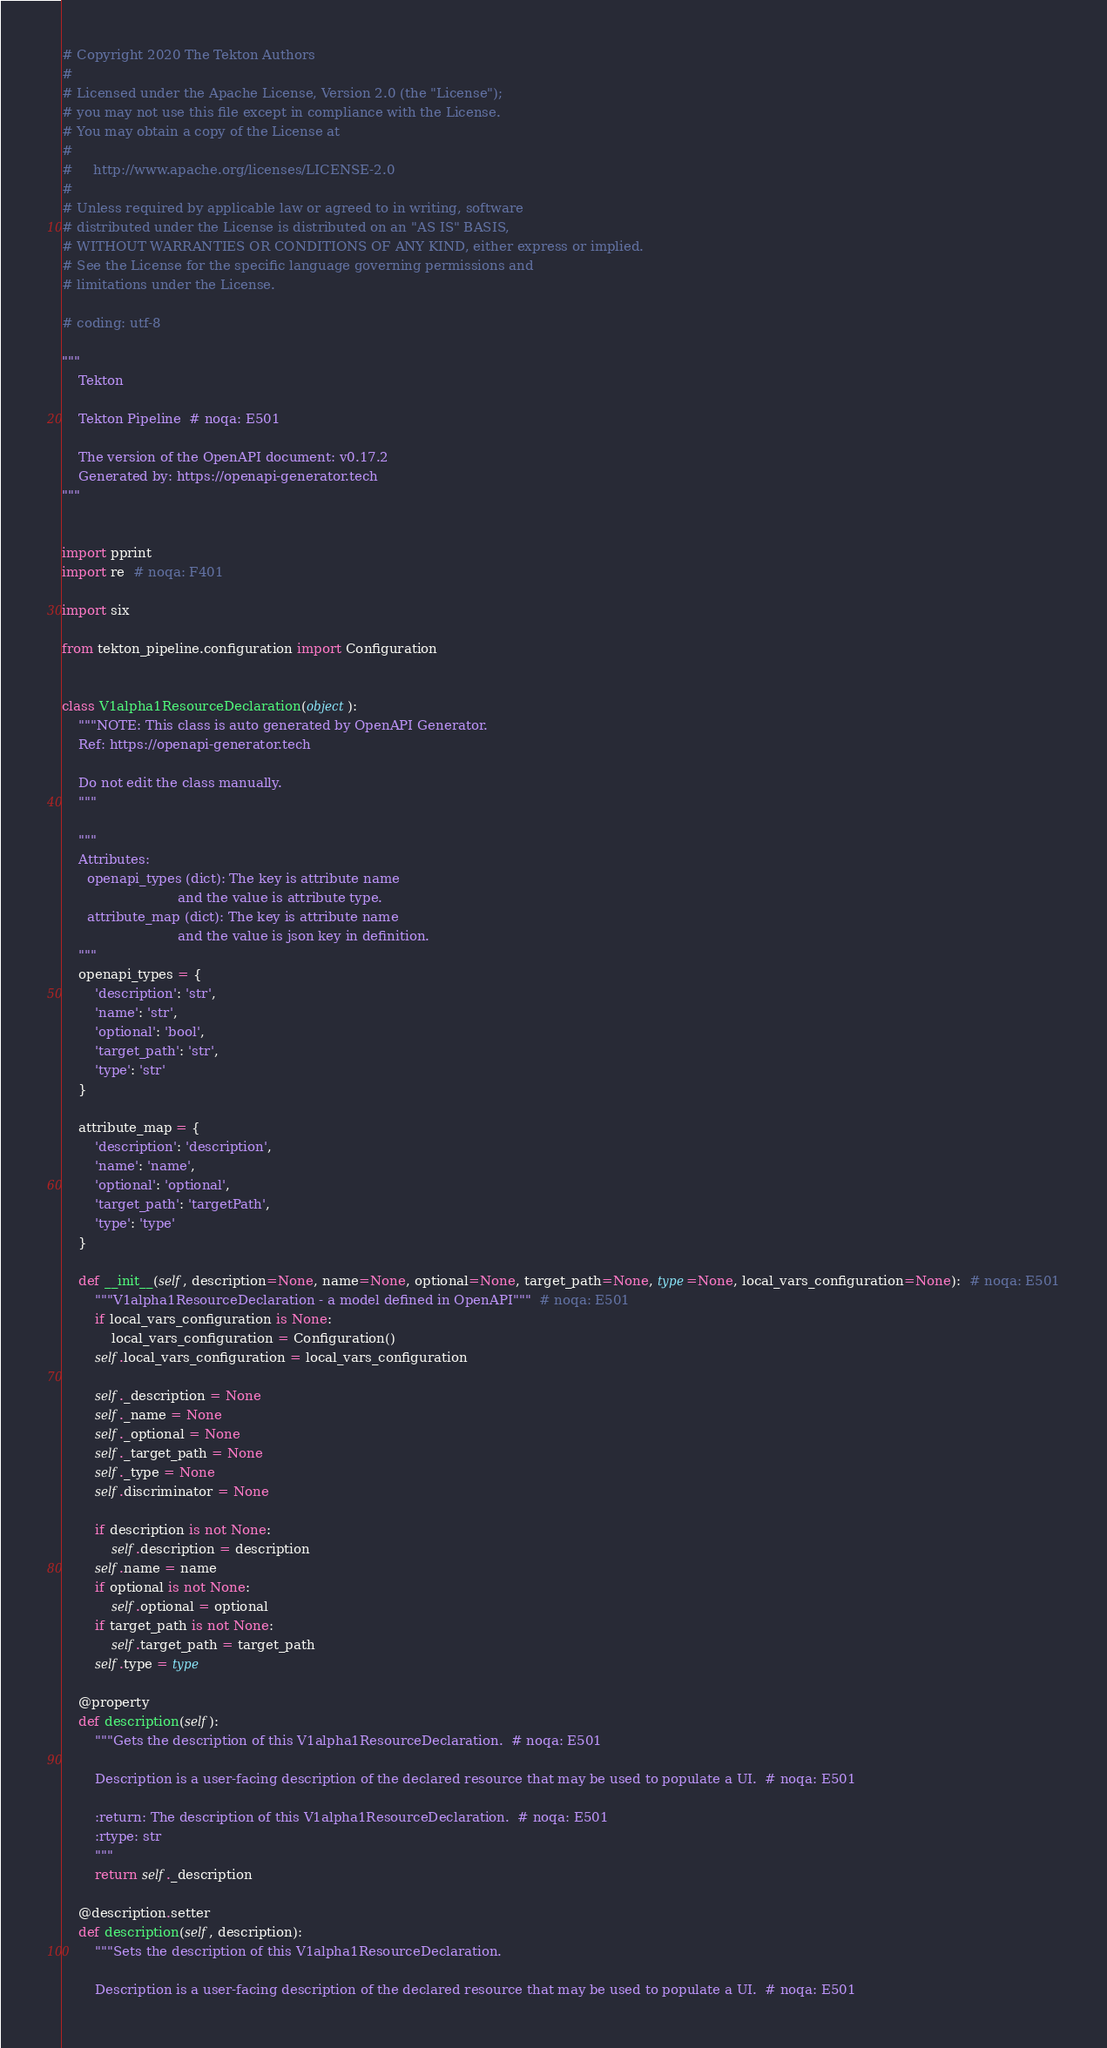Convert code to text. <code><loc_0><loc_0><loc_500><loc_500><_Python_># Copyright 2020 The Tekton Authors
#
# Licensed under the Apache License, Version 2.0 (the "License");
# you may not use this file except in compliance with the License.
# You may obtain a copy of the License at
#
#     http://www.apache.org/licenses/LICENSE-2.0
#
# Unless required by applicable law or agreed to in writing, software
# distributed under the License is distributed on an "AS IS" BASIS,
# WITHOUT WARRANTIES OR CONDITIONS OF ANY KIND, either express or implied.
# See the License for the specific language governing permissions and
# limitations under the License.

# coding: utf-8

"""
    Tekton

    Tekton Pipeline  # noqa: E501

    The version of the OpenAPI document: v0.17.2
    Generated by: https://openapi-generator.tech
"""


import pprint
import re  # noqa: F401

import six

from tekton_pipeline.configuration import Configuration


class V1alpha1ResourceDeclaration(object):
    """NOTE: This class is auto generated by OpenAPI Generator.
    Ref: https://openapi-generator.tech

    Do not edit the class manually.
    """

    """
    Attributes:
      openapi_types (dict): The key is attribute name
                            and the value is attribute type.
      attribute_map (dict): The key is attribute name
                            and the value is json key in definition.
    """
    openapi_types = {
        'description': 'str',
        'name': 'str',
        'optional': 'bool',
        'target_path': 'str',
        'type': 'str'
    }

    attribute_map = {
        'description': 'description',
        'name': 'name',
        'optional': 'optional',
        'target_path': 'targetPath',
        'type': 'type'
    }

    def __init__(self, description=None, name=None, optional=None, target_path=None, type=None, local_vars_configuration=None):  # noqa: E501
        """V1alpha1ResourceDeclaration - a model defined in OpenAPI"""  # noqa: E501
        if local_vars_configuration is None:
            local_vars_configuration = Configuration()
        self.local_vars_configuration = local_vars_configuration

        self._description = None
        self._name = None
        self._optional = None
        self._target_path = None
        self._type = None
        self.discriminator = None

        if description is not None:
            self.description = description
        self.name = name
        if optional is not None:
            self.optional = optional
        if target_path is not None:
            self.target_path = target_path
        self.type = type

    @property
    def description(self):
        """Gets the description of this V1alpha1ResourceDeclaration.  # noqa: E501

        Description is a user-facing description of the declared resource that may be used to populate a UI.  # noqa: E501

        :return: The description of this V1alpha1ResourceDeclaration.  # noqa: E501
        :rtype: str
        """
        return self._description

    @description.setter
    def description(self, description):
        """Sets the description of this V1alpha1ResourceDeclaration.

        Description is a user-facing description of the declared resource that may be used to populate a UI.  # noqa: E501
</code> 